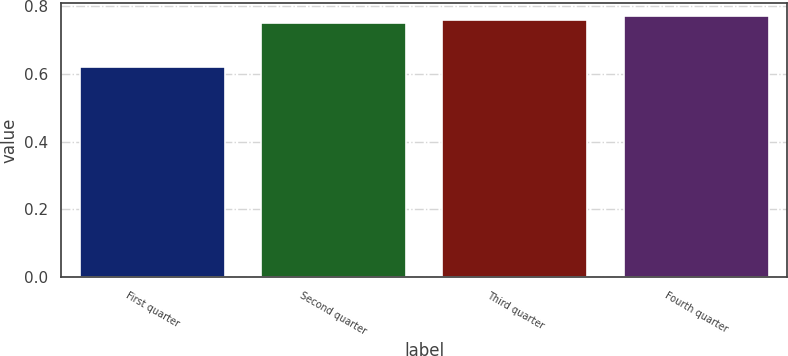Convert chart to OTSL. <chart><loc_0><loc_0><loc_500><loc_500><bar_chart><fcel>First quarter<fcel>Second quarter<fcel>Third quarter<fcel>Fourth quarter<nl><fcel>0.62<fcel>0.75<fcel>0.76<fcel>0.77<nl></chart> 